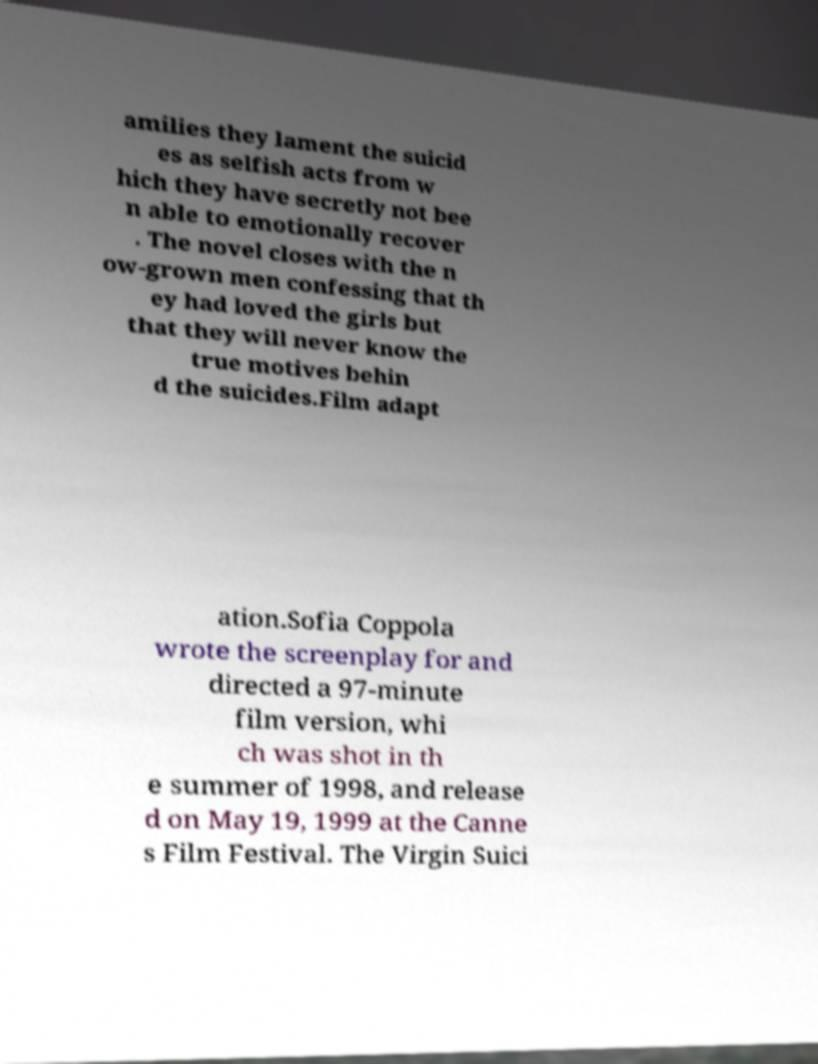Can you read and provide the text displayed in the image?This photo seems to have some interesting text. Can you extract and type it out for me? amilies they lament the suicid es as selfish acts from w hich they have secretly not bee n able to emotionally recover . The novel closes with the n ow-grown men confessing that th ey had loved the girls but that they will never know the true motives behin d the suicides.Film adapt ation.Sofia Coppola wrote the screenplay for and directed a 97-minute film version, whi ch was shot in th e summer of 1998, and release d on May 19, 1999 at the Canne s Film Festival. The Virgin Suici 